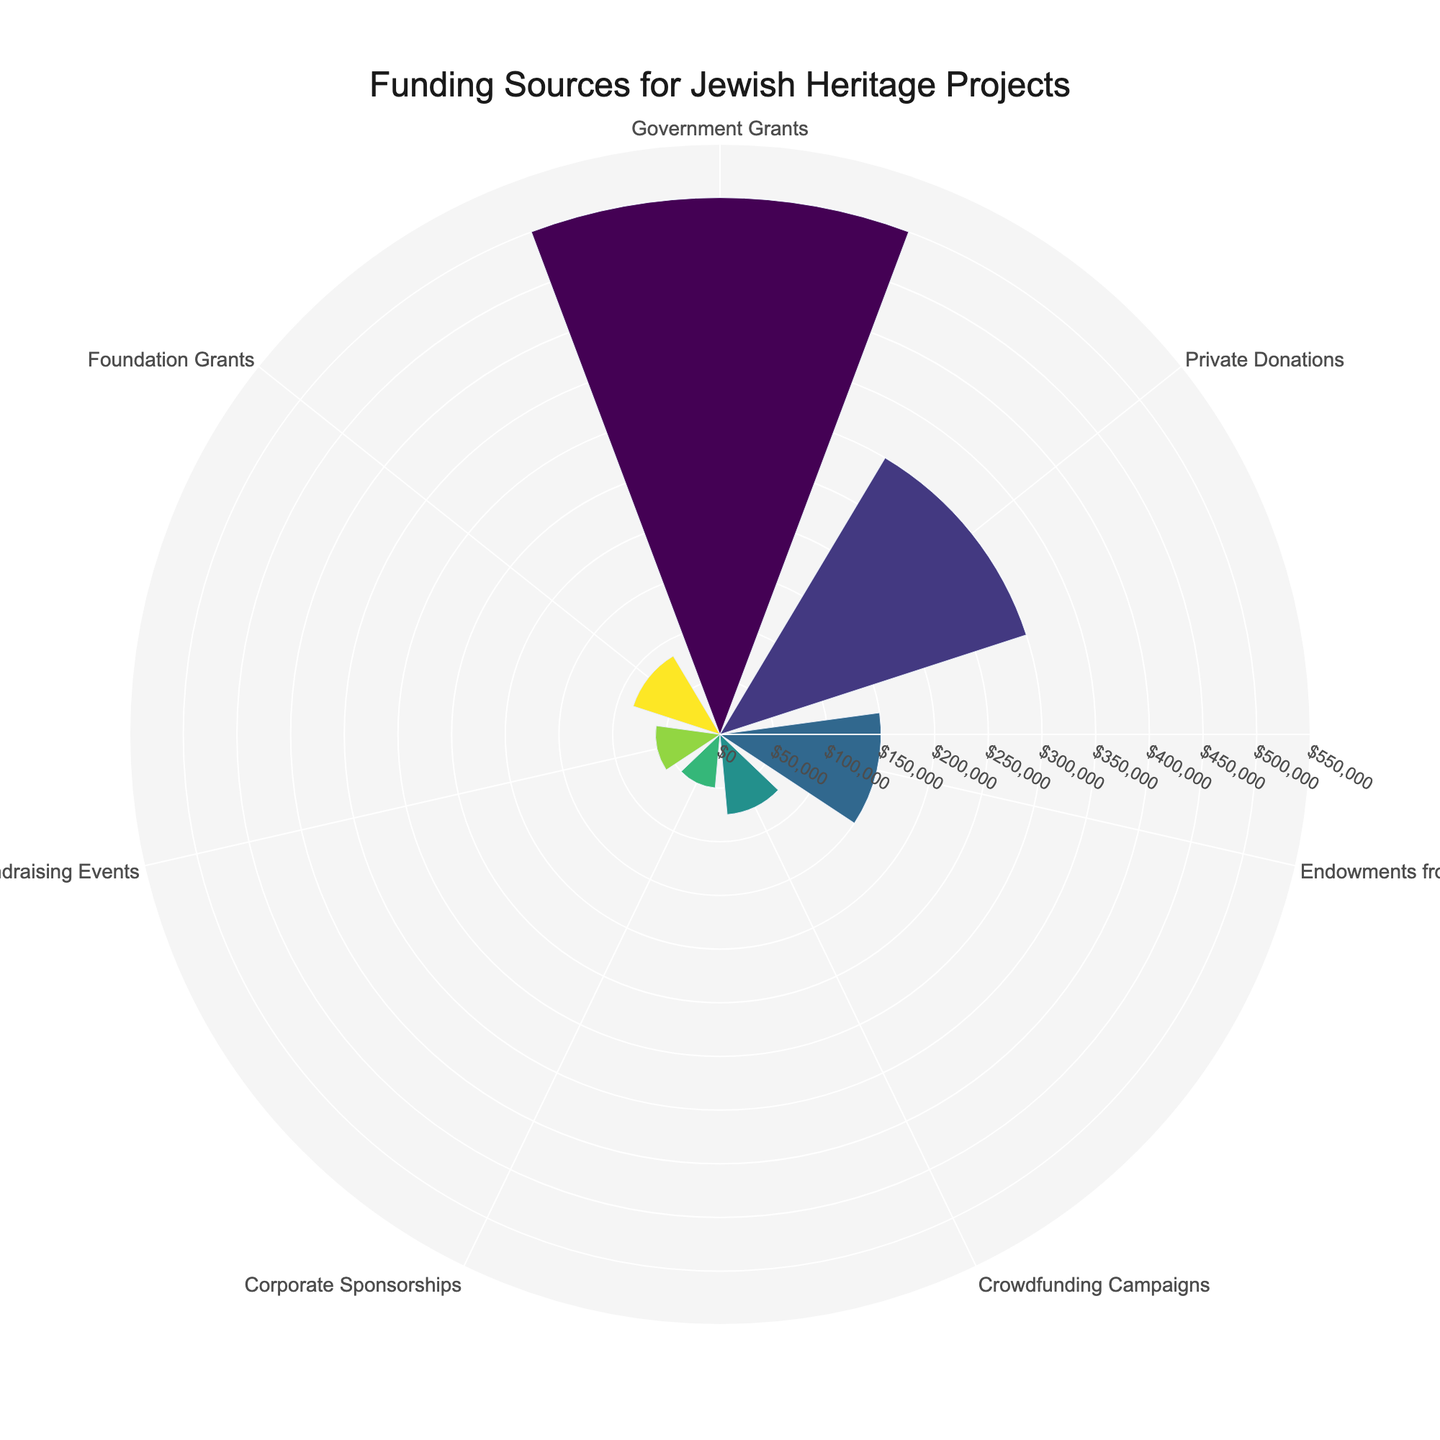What's the largest funding source for Jewish Heritage Projects? The largest funding source will be the segment with the longest radial distance (r) in the polar area chart. Based on the data, Government Grants has the highest amount.
Answer: Government Grants How much funding do Private Donations provide? Locate Private Donations in the chart and read its corresponding radial value (r). Based on the data, the amount is $300,000.
Answer: $300,000 What is the title of the chart? The title is prominently displayed above the polar area chart. It reads "Funding Sources for Jewish Heritage Projects."
Answer: Funding Sources for Jewish Heritage Projects What's the smallest funding source for Jewish Heritage Projects? The segment with the shortest radial distance (r) represents the smallest funding source. Based on the data, Corporate Sponsorships has the smallest amount.
Answer: Corporate Sponsorships How many funding sources are represented in the chart? Count the number of different types (segments) in the polar area chart. There are seven different funding sources listed in the data.
Answer: 7 What is the total amount of funding represented in the chart? Sum up all the amounts from the different funding sources: 500,000 + 300,000 + 150,000 + 75,000 + 50,000 + 60,000 + 85,000 = 1,220,000.
Answer: $1,220,000 Which funding source contributes 12.3% to the total funding? Percentages can be inferred from the annotations on each segment. For instance, the text "12.3%" would correspond to Foundation Grants, computed as (85,000/1,220,000) * 100 ≈ 12.3%.
Answer: Foundation Grants How does the amount from Endowments from Jewish Organizations compare to Corporate Sponsorships? Reference the radial distances (r) for Endowments from Jewish Organizations and Corporate Sponsorships. The amount from Endowments from Jewish Organizations ($150,000) is greater than that from Corporate Sponsorships ($50,000).
Answer: Greater Add the amounts for Crowdfunding Campaigns and Fundraising Events. How much more is it compared to Private Donations? Compute the sum for Crowdfunding Campaigns and Fundraising Events: 75,000 + 60,000 = 135,000. Then, subtract Private Donations' amount: 300,000 - 135,000 = 165,000.
Answer: $165,000 more What percentage of total funding comes from Government Grants? Divide the amount from Government Grants by the total funding and multiply by 100: (500,000 / 1,220,000) * 100 ≈ 41.0%.
Answer: 41.0% 